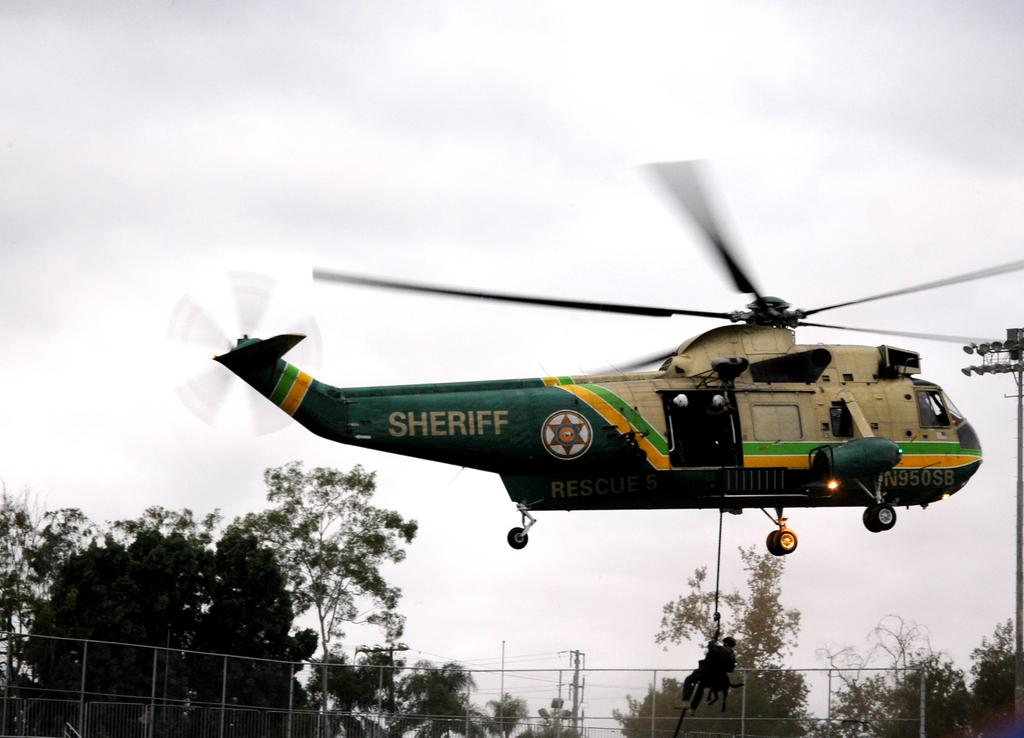<image>
Give a short and clear explanation of the subsequent image. the word sheriff is on the large helicopter 